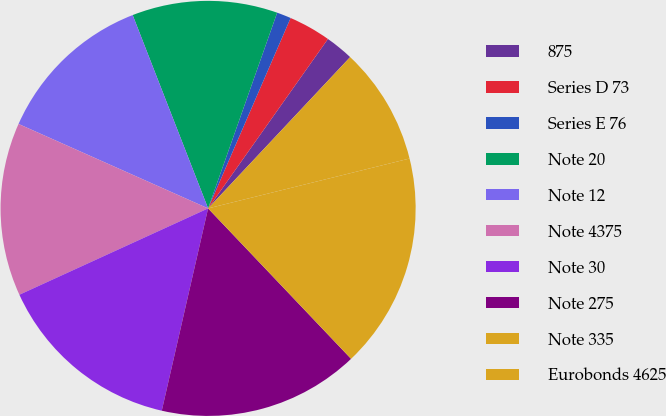Convert chart. <chart><loc_0><loc_0><loc_500><loc_500><pie_chart><fcel>875<fcel>Series D 73<fcel>Series E 76<fcel>Note 20<fcel>Note 12<fcel>Note 4375<fcel>Note 30<fcel>Note 275<fcel>Note 335<fcel>Eurobonds 4625<nl><fcel>2.2%<fcel>3.29%<fcel>1.11%<fcel>11.32%<fcel>12.41%<fcel>13.5%<fcel>14.59%<fcel>15.68%<fcel>16.77%<fcel>9.14%<nl></chart> 